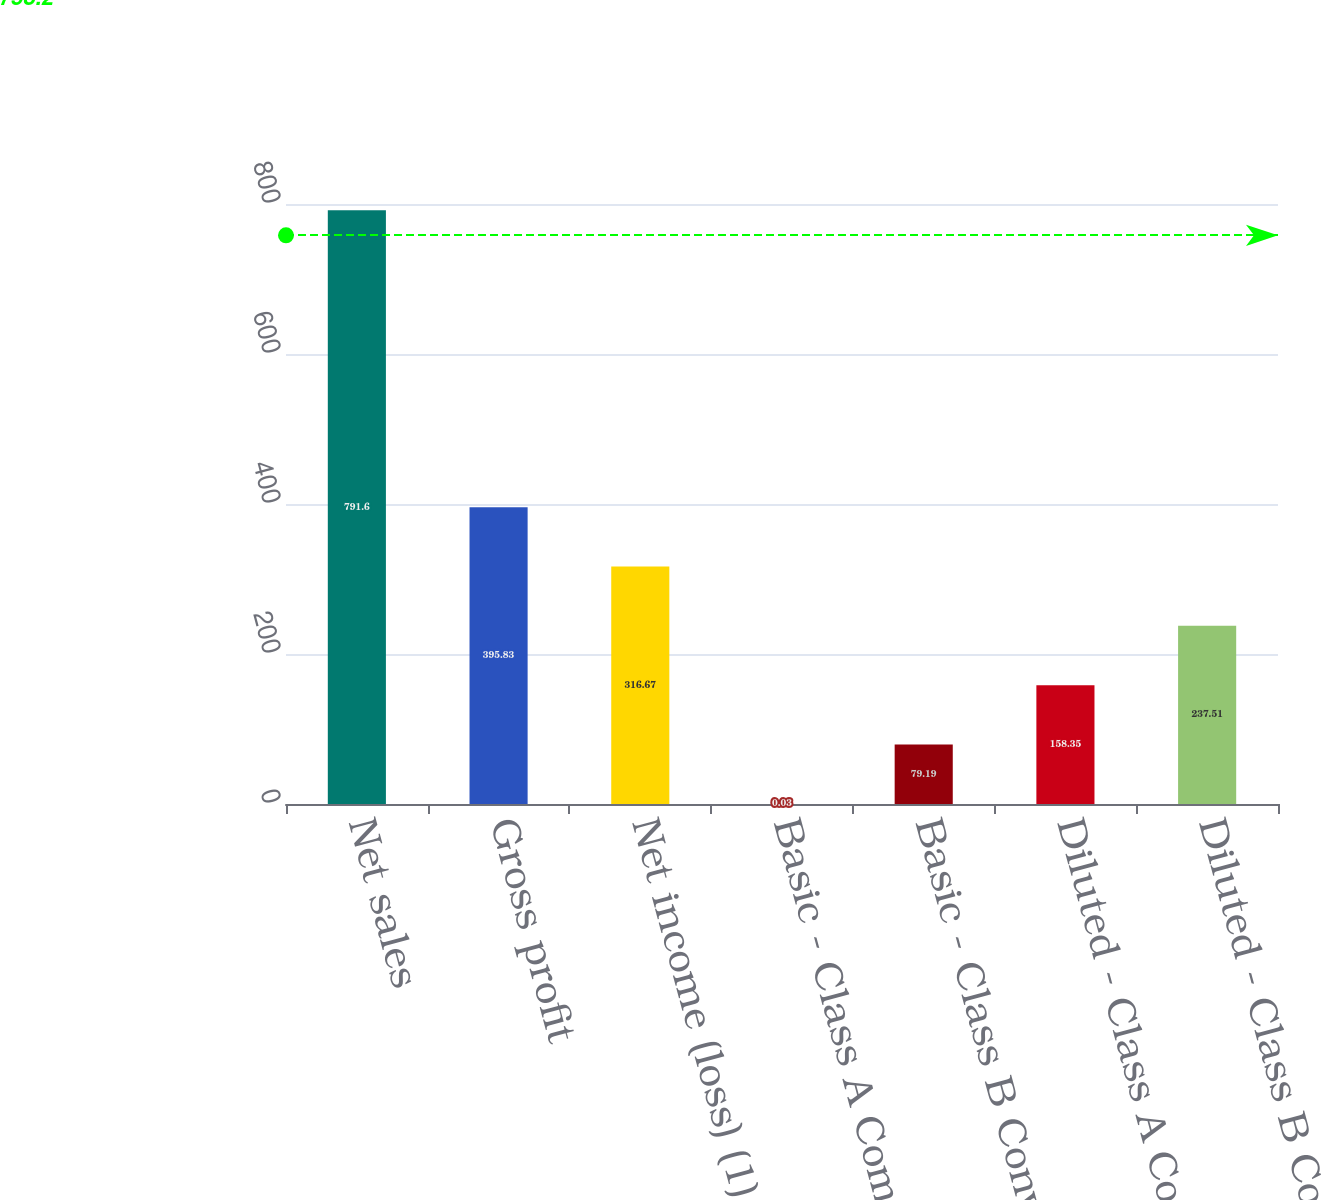Convert chart to OTSL. <chart><loc_0><loc_0><loc_500><loc_500><bar_chart><fcel>Net sales<fcel>Gross profit<fcel>Net income (loss) (1)<fcel>Basic - Class A Common Stock<fcel>Basic - Class B Convertible<fcel>Diluted - Class A Common Stock<fcel>Diluted - Class B Convertible<nl><fcel>791.6<fcel>395.83<fcel>316.67<fcel>0.03<fcel>79.19<fcel>158.35<fcel>237.51<nl></chart> 